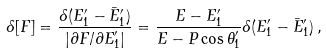<formula> <loc_0><loc_0><loc_500><loc_500>\delta [ F ] = \frac { \delta ( E ^ { \prime } _ { 1 } - { \bar { E } ^ { \prime } _ { 1 } } ) } { | \partial F / \partial E ^ { \prime } _ { 1 } | } = \frac { E - E ^ { \prime } _ { 1 } } { E - P \cos { \theta } ^ { \prime } _ { 1 } } \delta ( E ^ { \prime } _ { 1 } - { \bar { E } ^ { \prime } _ { 1 } } ) \, ,</formula> 